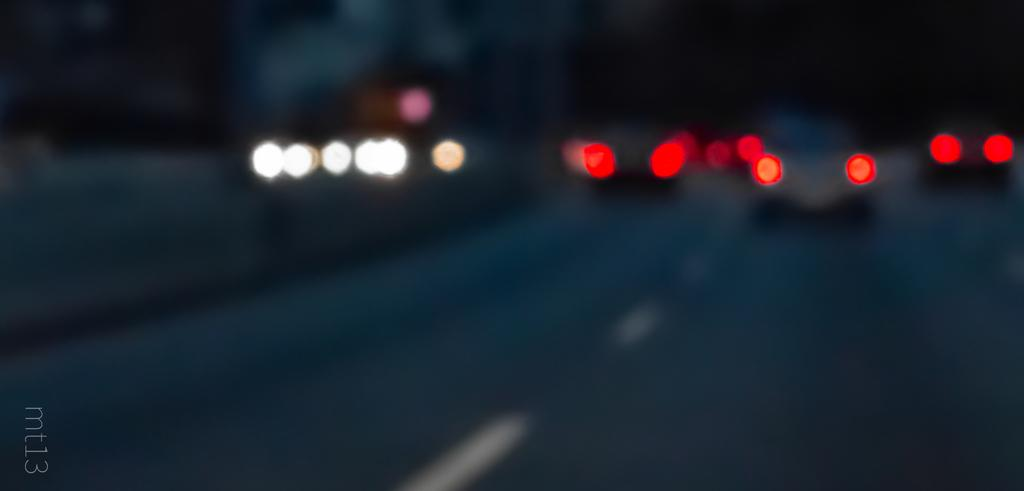What is the main feature of the image? There is a road in the image. What is happening on the road? Vehicles are present on the road. Can you describe the effect of the vehicles on the road? The light from the vehicles is visible on the road. Where are the fairies dancing in the image? There are no fairies present in the image. What type of cream is being used to pave the road in the image? The image does not show any cream being used to pave the road; it is a regular road with vehicles on it. 